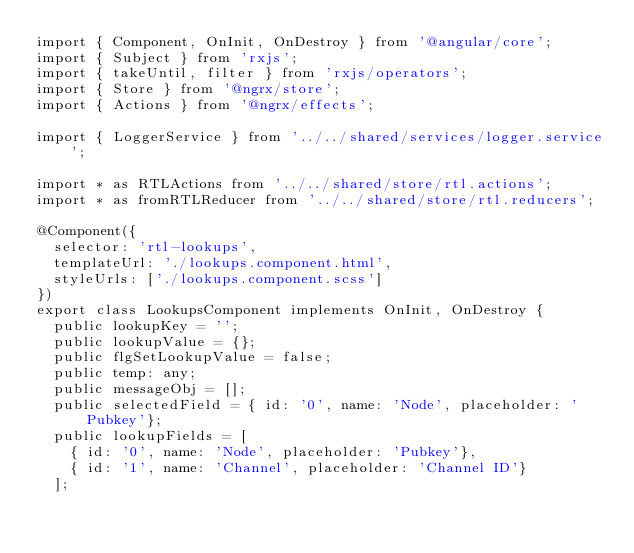<code> <loc_0><loc_0><loc_500><loc_500><_TypeScript_>import { Component, OnInit, OnDestroy } from '@angular/core';
import { Subject } from 'rxjs';
import { takeUntil, filter } from 'rxjs/operators';
import { Store } from '@ngrx/store';
import { Actions } from '@ngrx/effects';

import { LoggerService } from '../../shared/services/logger.service';

import * as RTLActions from '../../shared/store/rtl.actions';
import * as fromRTLReducer from '../../shared/store/rtl.reducers';

@Component({
  selector: 'rtl-lookups',
  templateUrl: './lookups.component.html',
  styleUrls: ['./lookups.component.scss']
})
export class LookupsComponent implements OnInit, OnDestroy {
  public lookupKey = '';
  public lookupValue = {};
  public flgSetLookupValue = false;
  public temp: any;
  public messageObj = [];
  public selectedField = { id: '0', name: 'Node', placeholder: 'Pubkey'};
  public lookupFields = [
    { id: '0', name: 'Node', placeholder: 'Pubkey'},
    { id: '1', name: 'Channel', placeholder: 'Channel ID'}
  ];</code> 